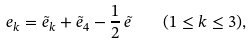Convert formula to latex. <formula><loc_0><loc_0><loc_500><loc_500>e _ { k } = \tilde { e } _ { k } + \tilde { e } _ { 4 } - { \frac { 1 } { 2 } } \, \tilde { e } \quad ( 1 \leq k \leq 3 ) ,</formula> 